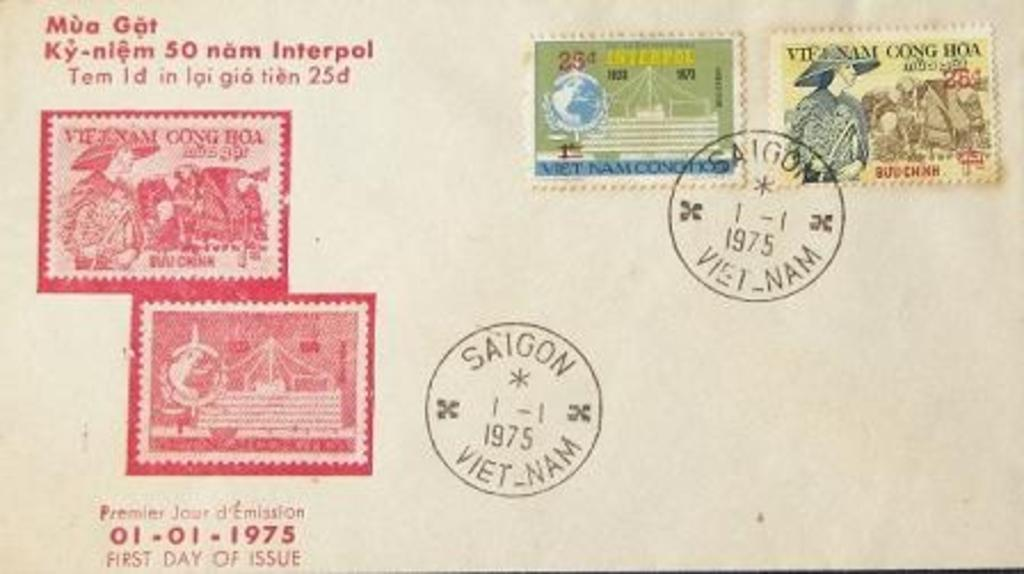<image>
Present a compact description of the photo's key features. the front of an old envelope, sent from saigon, vietnam, in 1975 